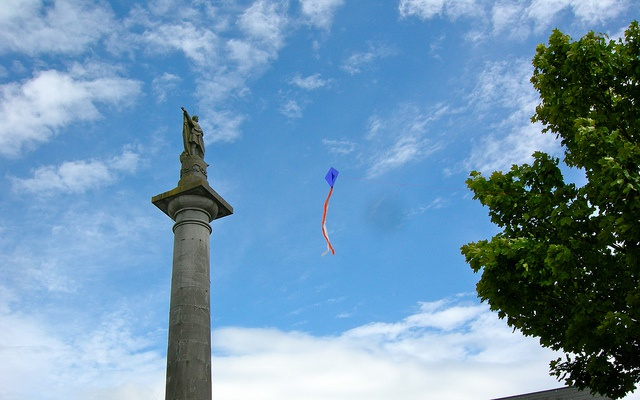Describe the objects in this image and their specific colors. I can see a kite in lightblue, blue, and darkgray tones in this image. 